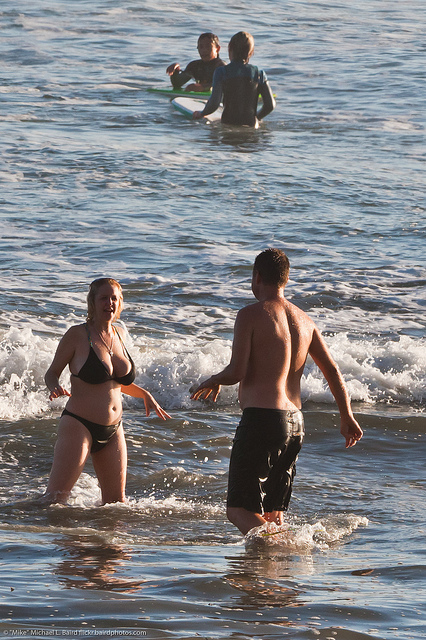Can you tell me about the people who are standing in the water? The two individuals standing in the water near the shore are likely enjoying a casual wade in the sea. One person is facing the camera and appears to be in mid-conversation or expression, animated by either the coolness of the water or the interaction itself. The other person, seen from behind, seems to be engaged in the exchange while also experiencing the ocean's refreshing touch. 